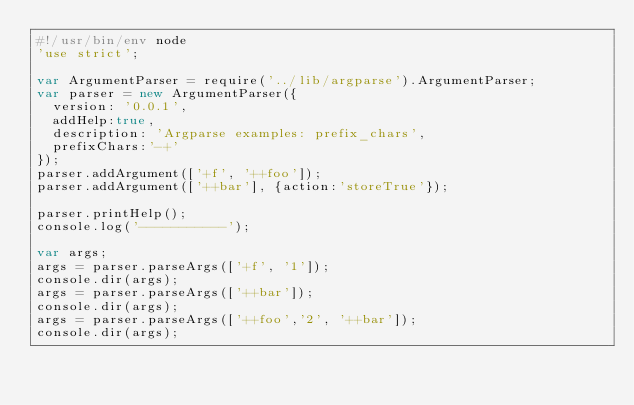<code> <loc_0><loc_0><loc_500><loc_500><_JavaScript_>#!/usr/bin/env node
'use strict';

var ArgumentParser = require('../lib/argparse').ArgumentParser;
var parser = new ArgumentParser({
  version: '0.0.1',
  addHelp:true,
  description: 'Argparse examples: prefix_chars',
  prefixChars:'-+'
});
parser.addArgument(['+f', '++foo']);
parser.addArgument(['++bar'], {action:'storeTrue'});

parser.printHelp();
console.log('-----------');

var args;
args = parser.parseArgs(['+f', '1']);
console.dir(args);
args = parser.parseArgs(['++bar']);
console.dir(args);
args = parser.parseArgs(['++foo','2', '++bar']);
console.dir(args);
</code> 